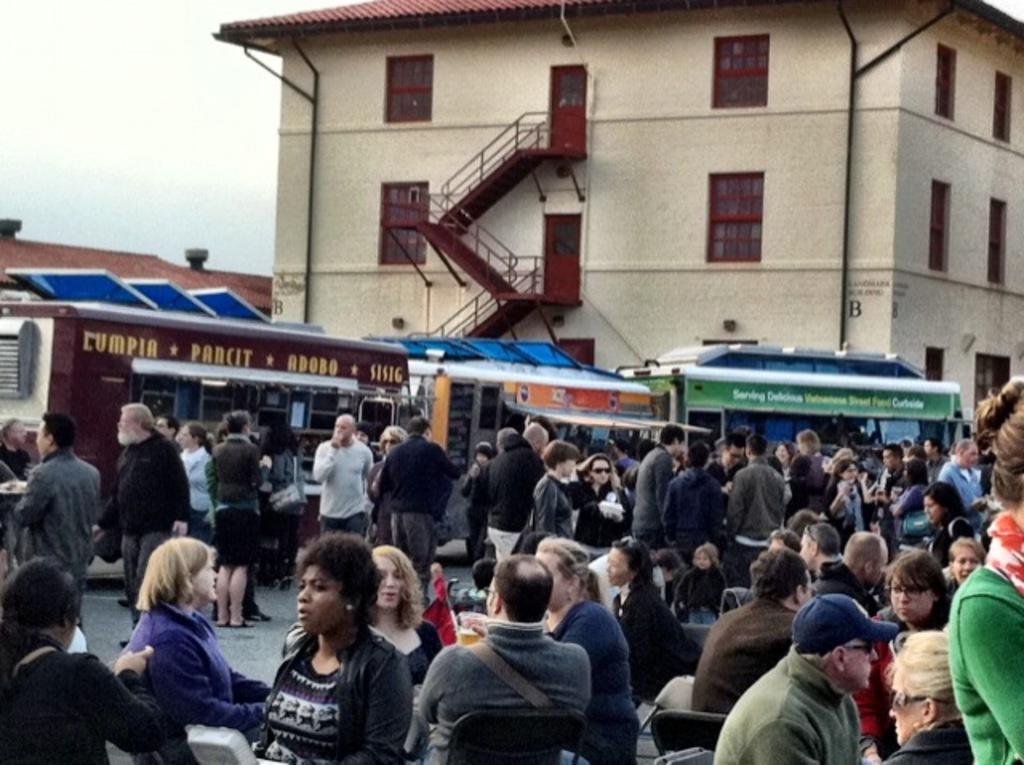Please provide a concise description of this image. There is a crowd at the bottom of this image. We can see buildings in the middle of this image and the sky is in the background. 